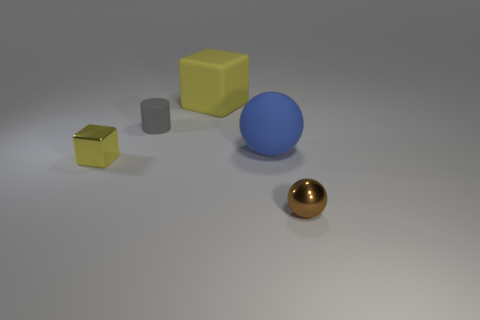There is a shiny object right of the yellow rubber object; does it have the same shape as the large object that is in front of the yellow matte thing?
Offer a very short reply. Yes. Is there a yellow thing that has the same size as the brown ball?
Provide a short and direct response. Yes. How many gray objects are either small matte things or tiny cubes?
Make the answer very short. 1. What number of large matte blocks have the same color as the shiny block?
Offer a terse response. 1. Are there any other things that have the same shape as the small gray object?
Offer a very short reply. No. What number of spheres are either brown metal objects or yellow shiny things?
Your response must be concise. 1. What is the color of the metal object on the right side of the tiny yellow object?
Make the answer very short. Brown. There is a yellow object that is the same size as the brown metal thing; what shape is it?
Offer a terse response. Cube. There is a large blue matte object; how many blocks are in front of it?
Your answer should be very brief. 1. What number of things are small gray matte objects or large matte blocks?
Your response must be concise. 2. 